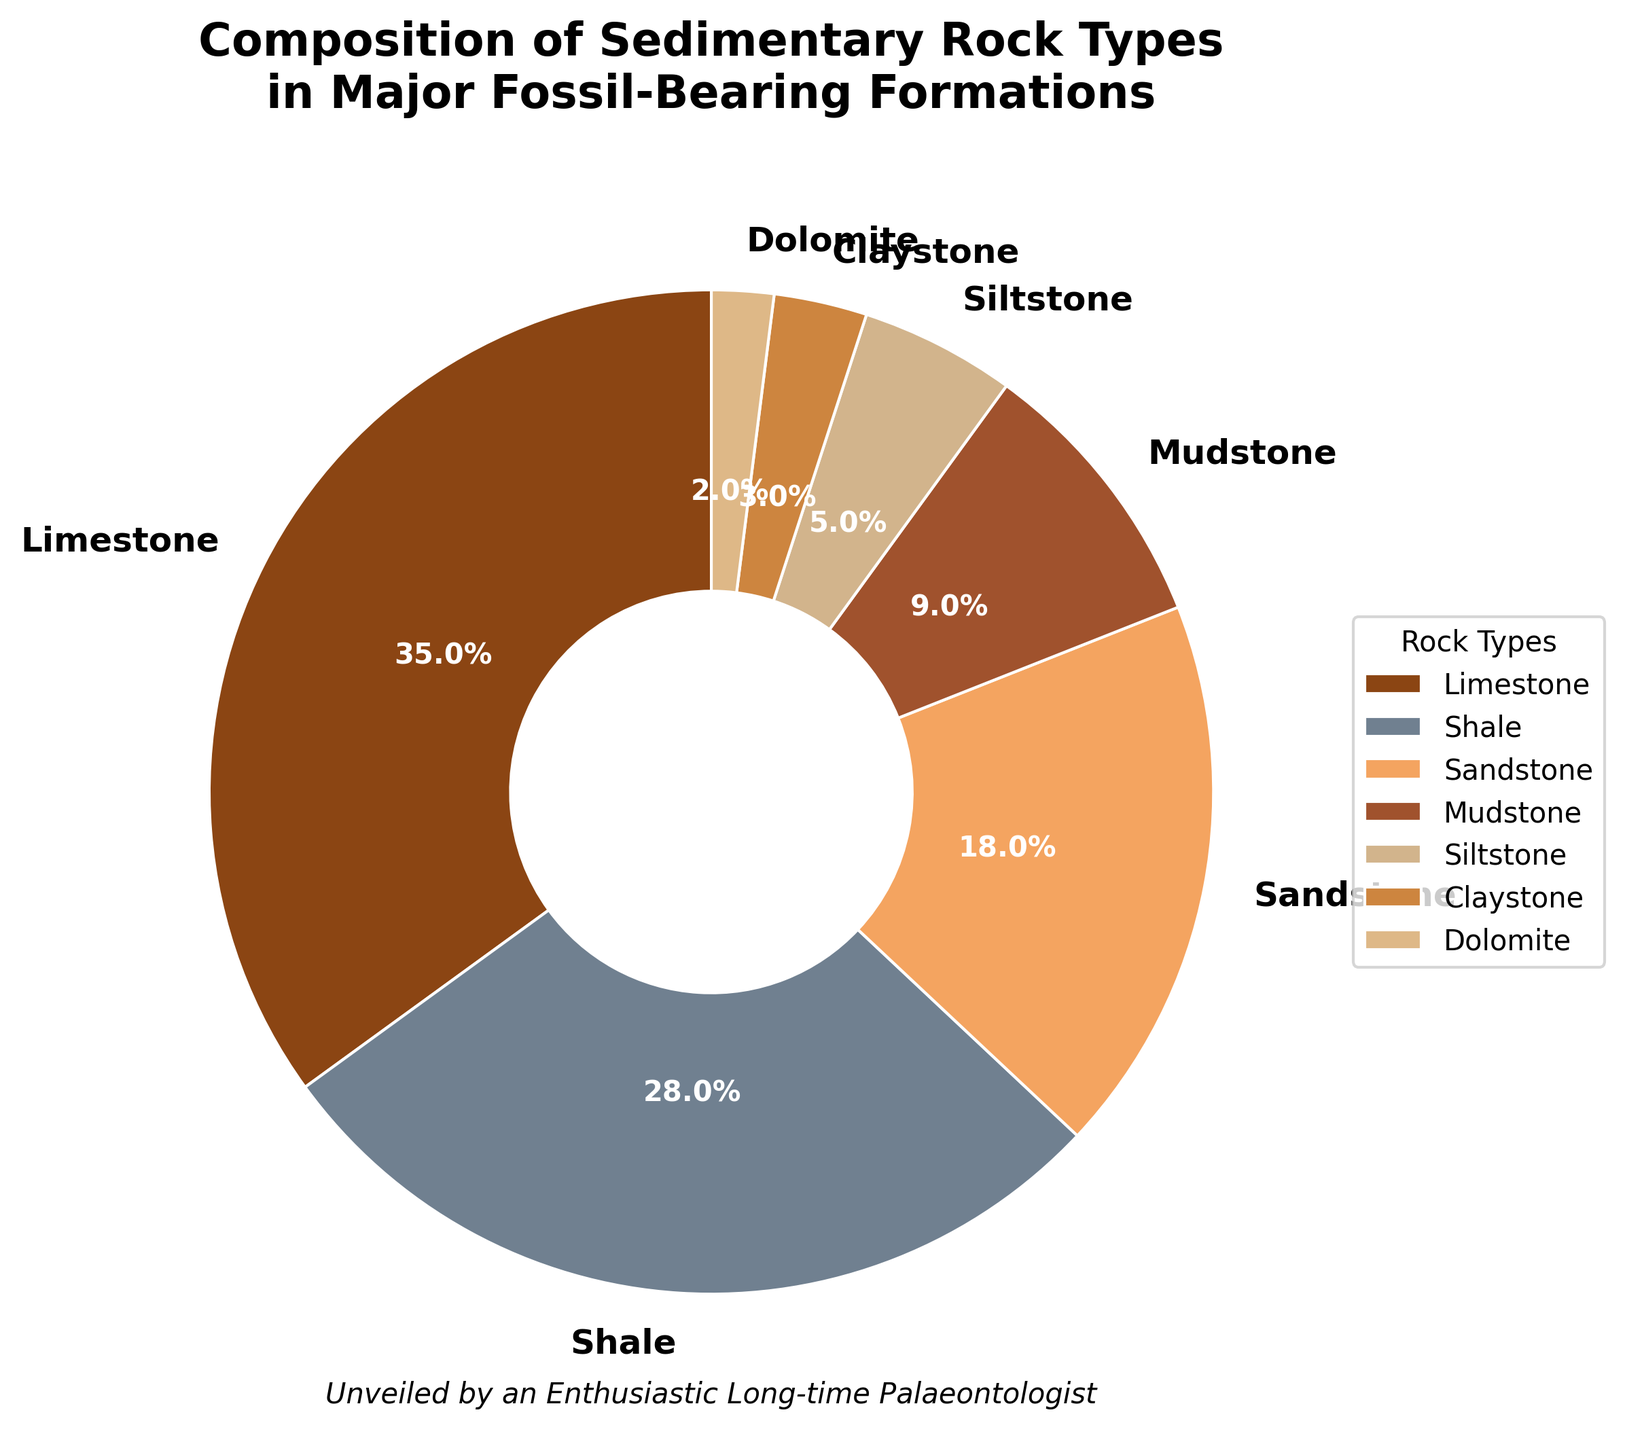What's the total percentage of Shale and Siltstone combined? To find the total percentage of Shale and Siltstone, you sum their individual percentages. Shale is 28% and Siltstone is 5%. Thus, 28 + 5 = 33%.
Answer: 33% Which rock type is the most dominant in major fossil-bearing formations? The pie chart shows that Limestone has the largest section, representing 35% of the total. Since 35% is the largest percentage, Limestone is the most dominant rock type.
Answer: Limestone How much more percentage does Limestone have compared to Sandstone? Limestone has a percentage of 35%, while Sandstone has 18%. To find the difference, subtract Sandstone's percentage from Limestone's percentage: 35 - 18 = 17%.
Answer: 17% What is the combined percentage of the three least common rock types? The three least common rock types are Claystone, Dolomite, and Siltstone with percentages of 3%, 2%, and 5% respectively. The combined percentage is 3% + 2% + 5% = 10%.
Answer: 10% How does the percentage of Shale compare to the percentage of Mudstone? Shale accounts for 28% while Mudstone accounts for 9%. To compare them, we see that Shale's percentage is significantly higher than Mudstone's.
Answer: Shale > Mudstone Which color represents Siltstone on the pie chart? By looking at the legend on the chart, Siltstone is colored in a lighter brownish hue. This color clearly matches one of the segments on the pie chart labeled "Siltstone."
Answer: Light brownish hue What is the difference in percentage between the second most common and the least common rock types? The second most common rock type is Shale at 28% and the least common is Dolomite at 2%. The difference in percentage is 28 - 2 = 26%.
Answer: 26% How many rock types have a percentage higher than 20%? The rock types with more than 20% are Limestone (35%) and Shale (28%). Counting these two, we find that there are 2 rock types with a percentage higher than 20%.
Answer: 2 rock types What's the sum of percentages for Mudstone and Claystone? Adding the percentages of Mudstone (9%) and Claystone (3%) gives us 9 + 3 = 12%.
Answer: 12% Is the percentage of Sandstone more or less than one-third of the total pie chart? One-third of a pie chart represents approximately 33.33%. The segment for Sandstone is 18%, which is clearly less than this.
Answer: Less 